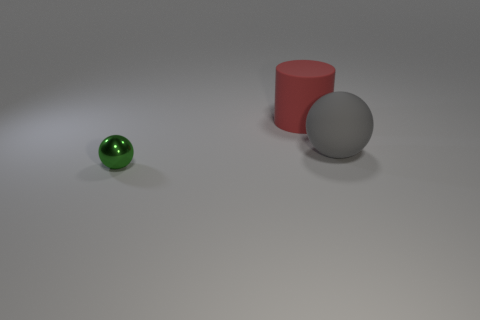How big is the thing in front of the big matte object that is in front of the red matte cylinder? The object in front of the large matte sphere appears to be relatively small, especially when compared to the scale of the sphere and the red cylinder behind it. Specifically, it's a small green sphere with a reflective surface that stands out against the larger, more muted objects. 